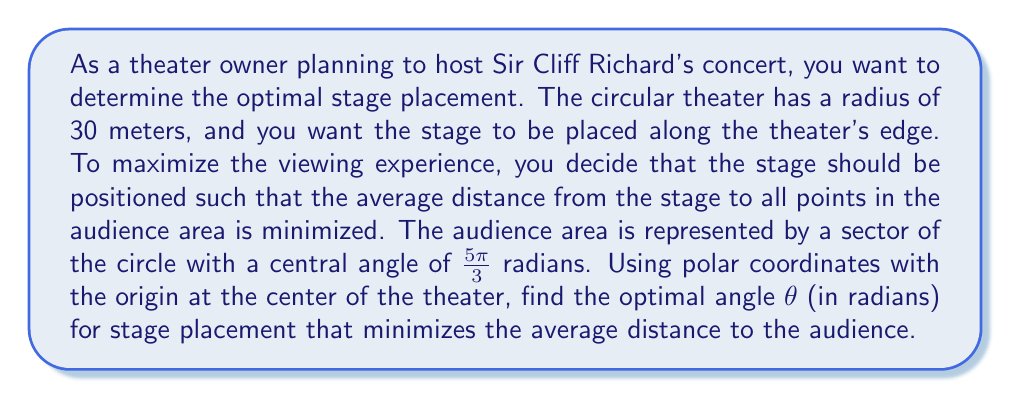Show me your answer to this math problem. Let's approach this step-by-step:

1) In polar coordinates, we can represent any point in the audience area as $(r,\phi)$, where $0 \leq r \leq 30$ and $0 \leq \phi \leq \frac{5\pi}{3}$.

2) If we place the stage at $(30,\theta)$, the distance from any point $(r,\phi)$ in the audience to the stage is given by:

   $$d(r,\phi) = \sqrt{r^2 + 30^2 - 60r\cos(\phi-\theta)}$$

3) The average distance is the integral of this distance over the audience area, divided by the area:

   $$D(\theta) = \frac{\int_0^{30}\int_0^{\frac{5\pi}{3}} \sqrt{r^2 + 30^2 - 60r\cos(\phi-\theta)} \cdot r \, d\phi \, dr}{\int_0^{30}\int_0^{\frac{5\pi}{3}} r \, d\phi \, dr}$$

4) To minimize this, we need to find $\theta$ where $\frac{dD}{d\theta} = 0$. However, this is a complex integral that's difficult to solve analytically.

5) We can simplify by recognizing that due to the symmetry of the problem, the optimal placement will be at the center of the audience sector.

6) The audience sector spans from $0$ to $\frac{5\pi}{3}$, so its center is at:

   $$\theta = \frac{1}{2} \cdot \frac{5\pi}{3} = \frac{5\pi}{6}$$

7) This placement ensures that the stage is equidistant from both edges of the audience sector, which minimizes the average distance.
Answer: The optimal angle for stage placement is $\theta = \frac{5\pi}{6}$ radians. 